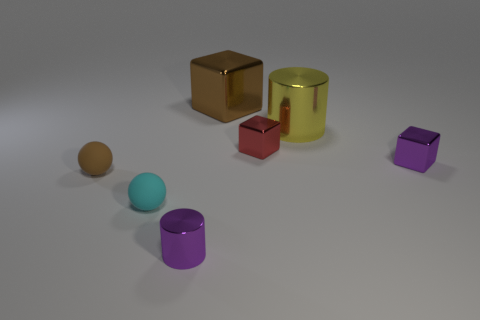What color is the tiny shiny block behind the object on the right side of the large cylinder?
Offer a terse response. Red. The small thing that is to the left of the purple shiny cylinder and to the right of the brown matte object is made of what material?
Your answer should be very brief. Rubber. Is there a big brown metal thing of the same shape as the tiny red shiny object?
Your response must be concise. Yes. There is a big thing that is behind the yellow metallic cylinder; does it have the same shape as the tiny red thing?
Provide a short and direct response. Yes. What number of tiny purple metal objects are both in front of the small purple metal block and behind the small cylinder?
Offer a very short reply. 0. The small metal thing behind the purple metallic block has what shape?
Your answer should be very brief. Cube. What number of objects are the same material as the tiny cylinder?
Your response must be concise. 4. There is a large brown object; is its shape the same as the tiny red thing that is right of the tiny cyan sphere?
Your response must be concise. Yes. There is a purple shiny object that is behind the matte thing that is behind the cyan rubber thing; is there a tiny metallic thing behind it?
Your answer should be compact. Yes. How big is the metal cylinder on the left side of the brown cube?
Your answer should be compact. Small. 